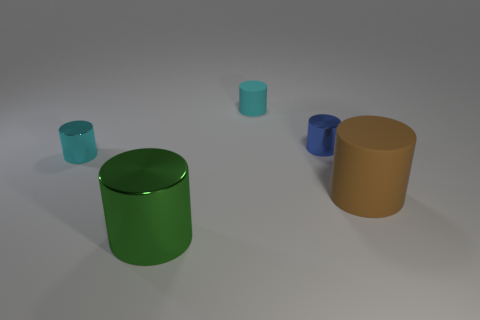There is a metallic object in front of the cyan metal thing; what size is it?
Your answer should be very brief. Large. There is a cyan object in front of the blue metal cylinder; is its size the same as the small rubber thing?
Provide a succinct answer. Yes. Are there any other things that are the same color as the large matte cylinder?
Offer a terse response. No. What is the shape of the big brown matte object?
Keep it short and to the point. Cylinder. What number of objects are both in front of the blue metallic cylinder and to the left of the tiny blue metal cylinder?
Make the answer very short. 2. Is the big metallic thing the same color as the large matte thing?
Make the answer very short. No. What material is the other blue object that is the same shape as the large metallic thing?
Ensure brevity in your answer.  Metal. Are there the same number of brown things that are behind the large rubber thing and tiny cyan objects left of the tiny blue object?
Provide a succinct answer. No. Is the small blue cylinder made of the same material as the green cylinder?
Provide a short and direct response. Yes. What number of purple things are either big metallic cylinders or rubber cylinders?
Your answer should be compact. 0. 